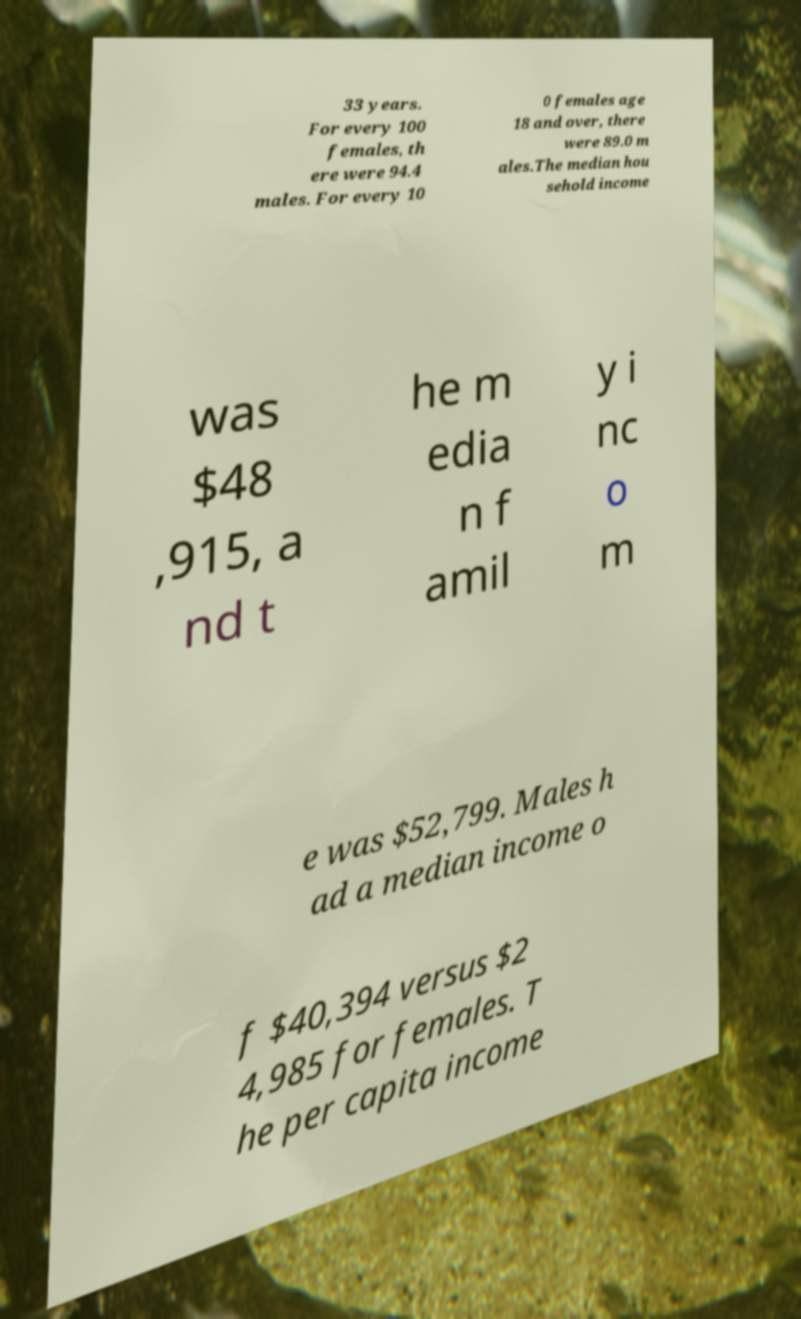Could you assist in decoding the text presented in this image and type it out clearly? 33 years. For every 100 females, th ere were 94.4 males. For every 10 0 females age 18 and over, there were 89.0 m ales.The median hou sehold income was $48 ,915, a nd t he m edia n f amil y i nc o m e was $52,799. Males h ad a median income o f $40,394 versus $2 4,985 for females. T he per capita income 